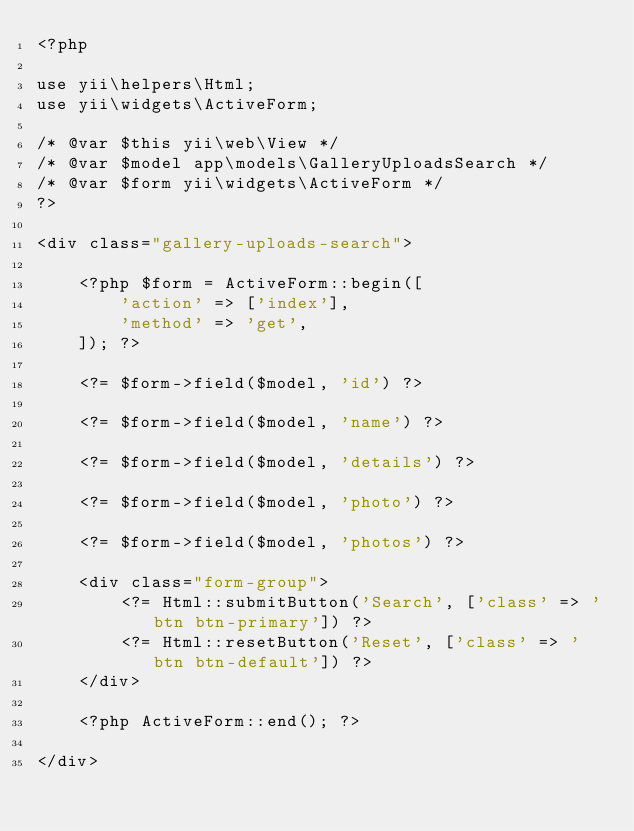Convert code to text. <code><loc_0><loc_0><loc_500><loc_500><_PHP_><?php

use yii\helpers\Html;
use yii\widgets\ActiveForm;

/* @var $this yii\web\View */
/* @var $model app\models\GalleryUploadsSearch */
/* @var $form yii\widgets\ActiveForm */
?>

<div class="gallery-uploads-search">

    <?php $form = ActiveForm::begin([
        'action' => ['index'],
        'method' => 'get',
    ]); ?>

    <?= $form->field($model, 'id') ?>

    <?= $form->field($model, 'name') ?>

    <?= $form->field($model, 'details') ?>

    <?= $form->field($model, 'photo') ?>

    <?= $form->field($model, 'photos') ?>

    <div class="form-group">
        <?= Html::submitButton('Search', ['class' => 'btn btn-primary']) ?>
        <?= Html::resetButton('Reset', ['class' => 'btn btn-default']) ?>
    </div>

    <?php ActiveForm::end(); ?>

</div>
</code> 